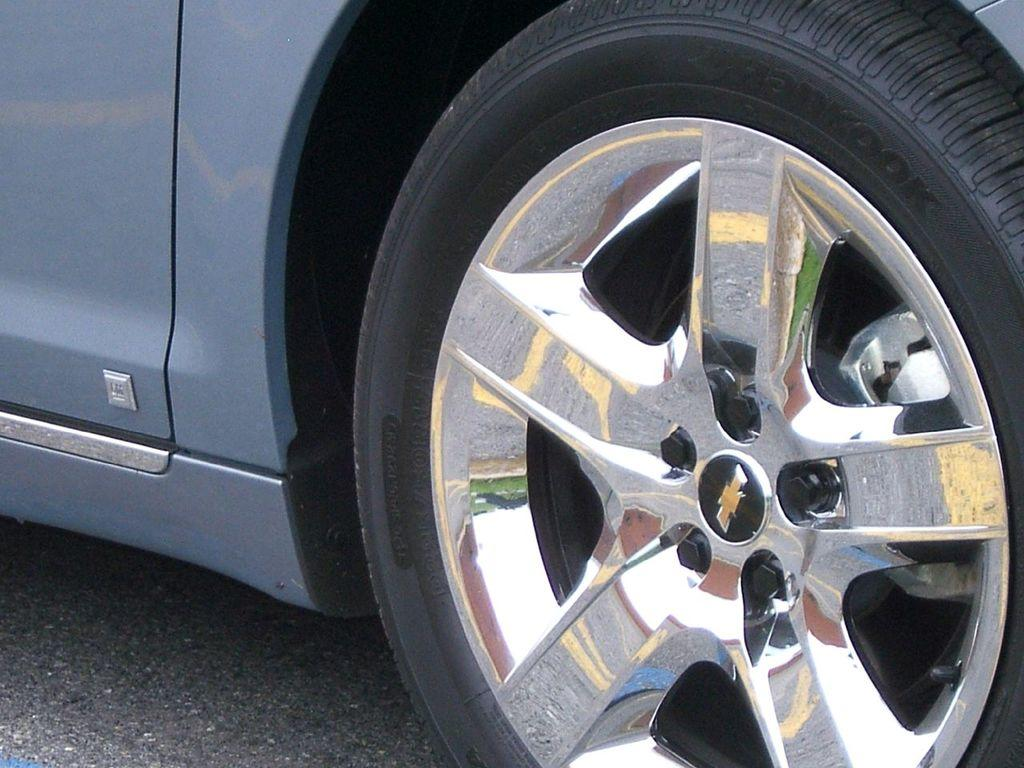What object is the main focus of the image? The main focus of the image is a car wheel. What type of material is the car wheel made of? The car wheel has wheel alloys. What is the color of the car in the image? The car is silver in color. Where is the car located in the image? The car is on the road. What type of cloth is used to cover the animals at the zoo in the image? There is no zoo or animals present in the image; it features a car wheel with wheel alloys and a silver car on the road. 